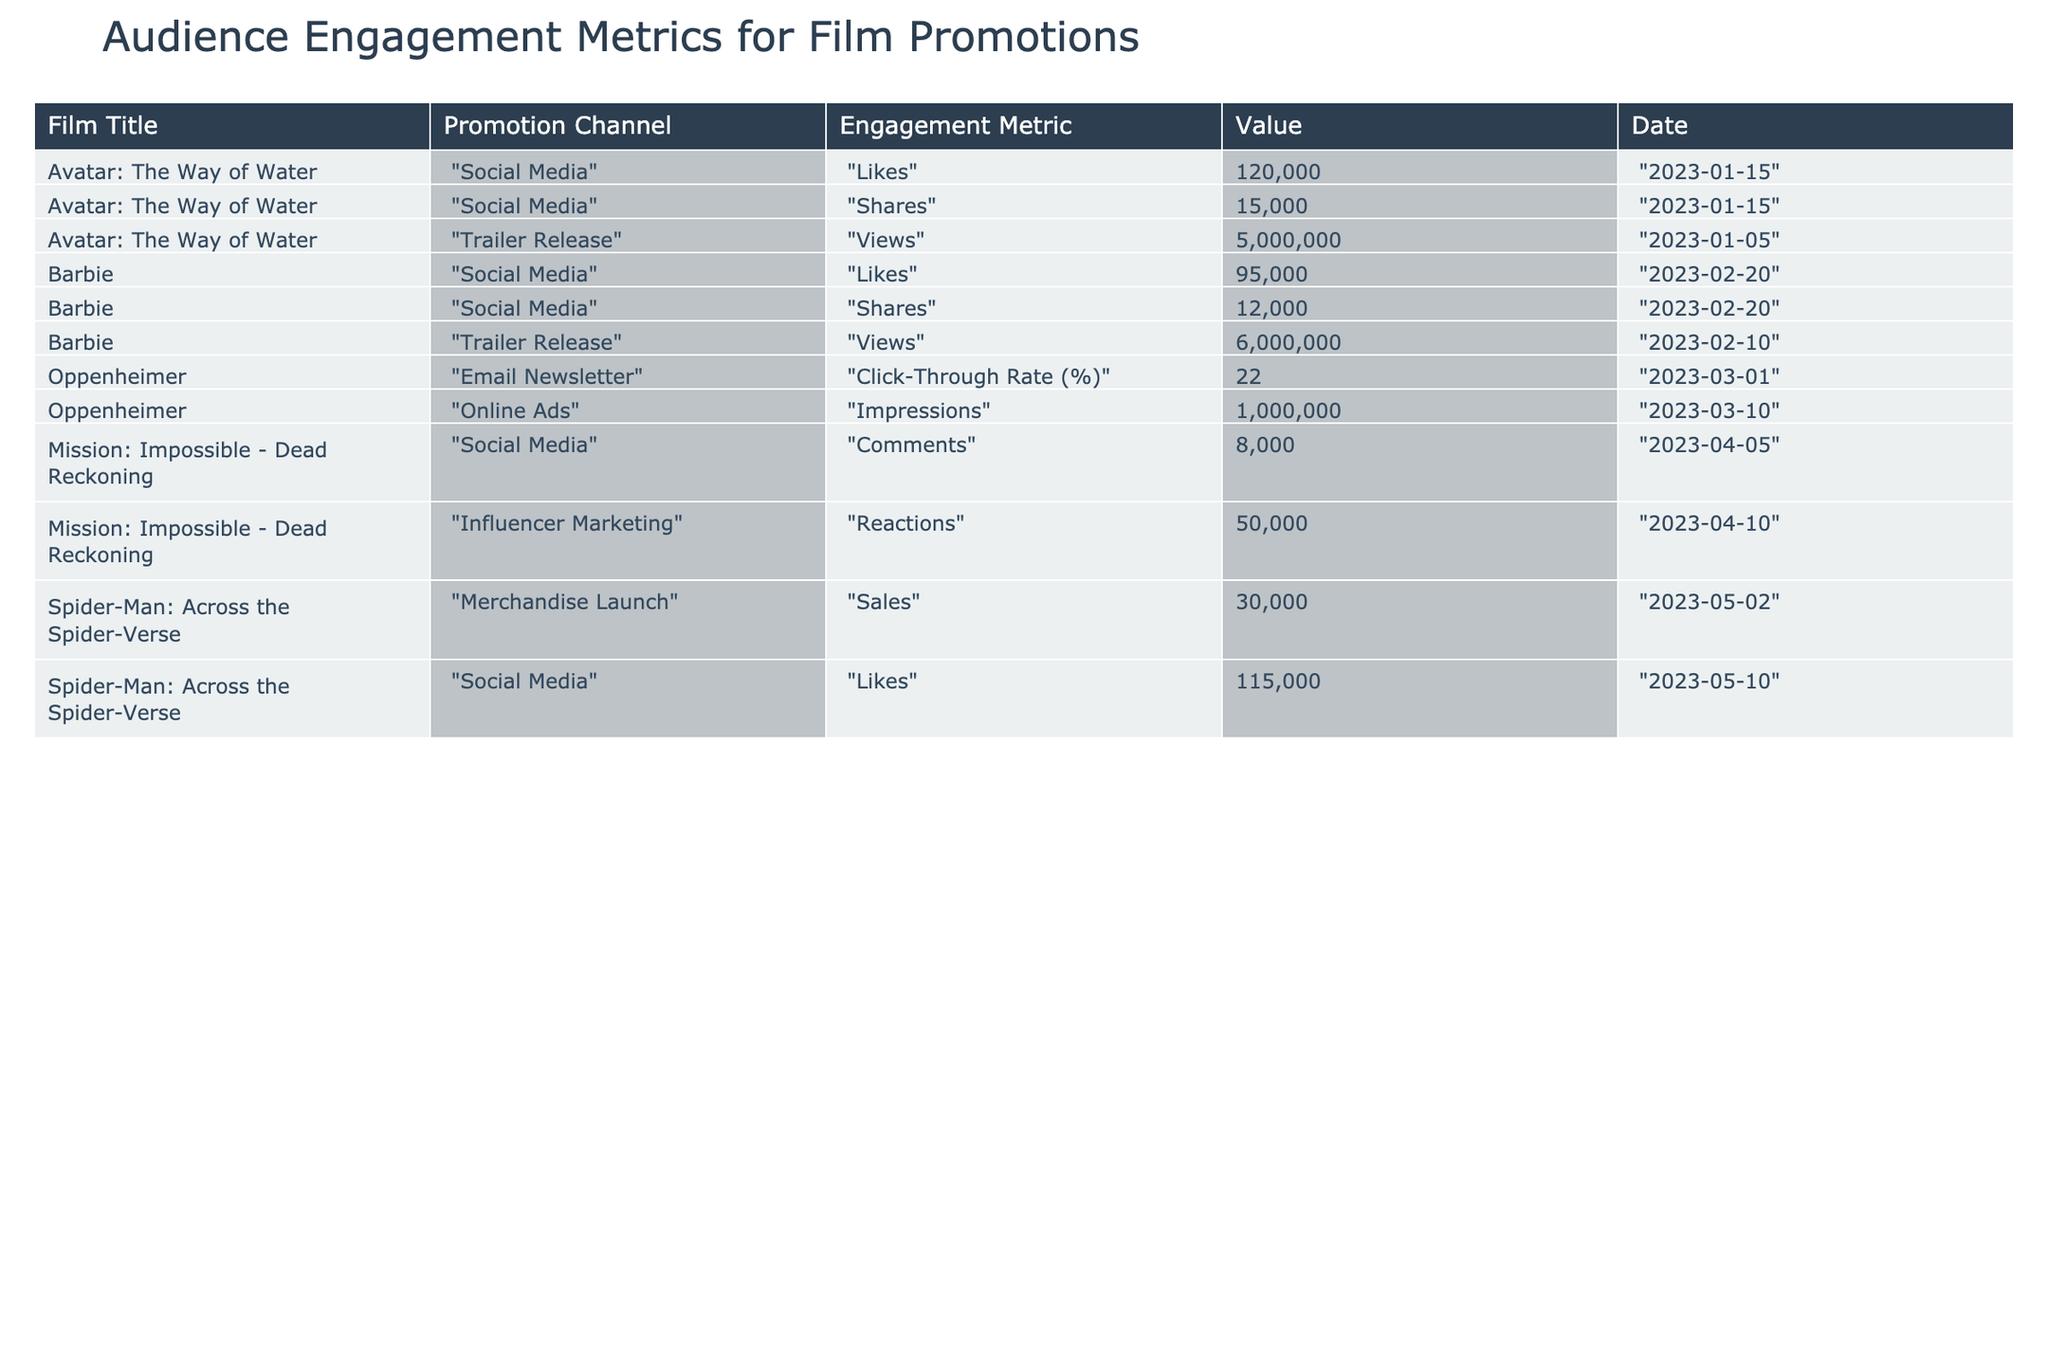What is the highest number of likes recorded for a film promotion? Upon reviewing the table, the highest number of likes comes from "Avatar: The Way of Water" with 120,000 likes.
Answer: 120,000 What film had the most views from a trailer release? The film with the most views is "Barbie," which had 6,000,000 views from its trailer release.
Answer: 6,000,000 What was the click-through rate for the email newsletter promoting "Oppenheimer"? The click-through rate from the email newsletter for "Oppenheimer" was 22%.
Answer: 22% Which film had the lowest number of comments on social media? The film with the lowest number of comments is "Mission: Impossible - Dead Reckoning," which had 8,000 comments on social media.
Answer: 8,000 What is the total number of shares for "Barbie" across promotions? "Barbie" had 12,000 shares from social media, therefore total shares is 12,000. There are no other share metrics for this film.
Answer: 12,000 Did "Spider-Man: Across the Spider-Verse" generate more sales through merchandise than "Avatar: The Way of Water" generated in likes? "Spider-Man: Across the Spider-Verse" had 30,000 sales, while "Avatar: The Way of Water" had 120,000 likes, which is significantly more. Therefore, "Avatar: The Way of Water" generated more.
Answer: No Which promotion channel had the highest impression count? The "Online Ads" channel for "Oppenheimer" recorded the highest impressions at 1,000,000.
Answer: 1,000,000 How many total reactions were recorded for "Mission: Impossible - Dead Reckoning"? Adding 50,000 reactions from influencer marketing and noting there are no other contributions listed for this film, the total is 50,000 reactions.
Answer: 50,000 What is the average number of likes for the two films "Avatar: The Way of Water" and "Barbie"? The likes total 120,000 for "Avatar: The Way of Water" and 95,000 for "Barbie," so the average is (120,000 + 95,000) / 2 = 107,500.
Answer: 107,500 